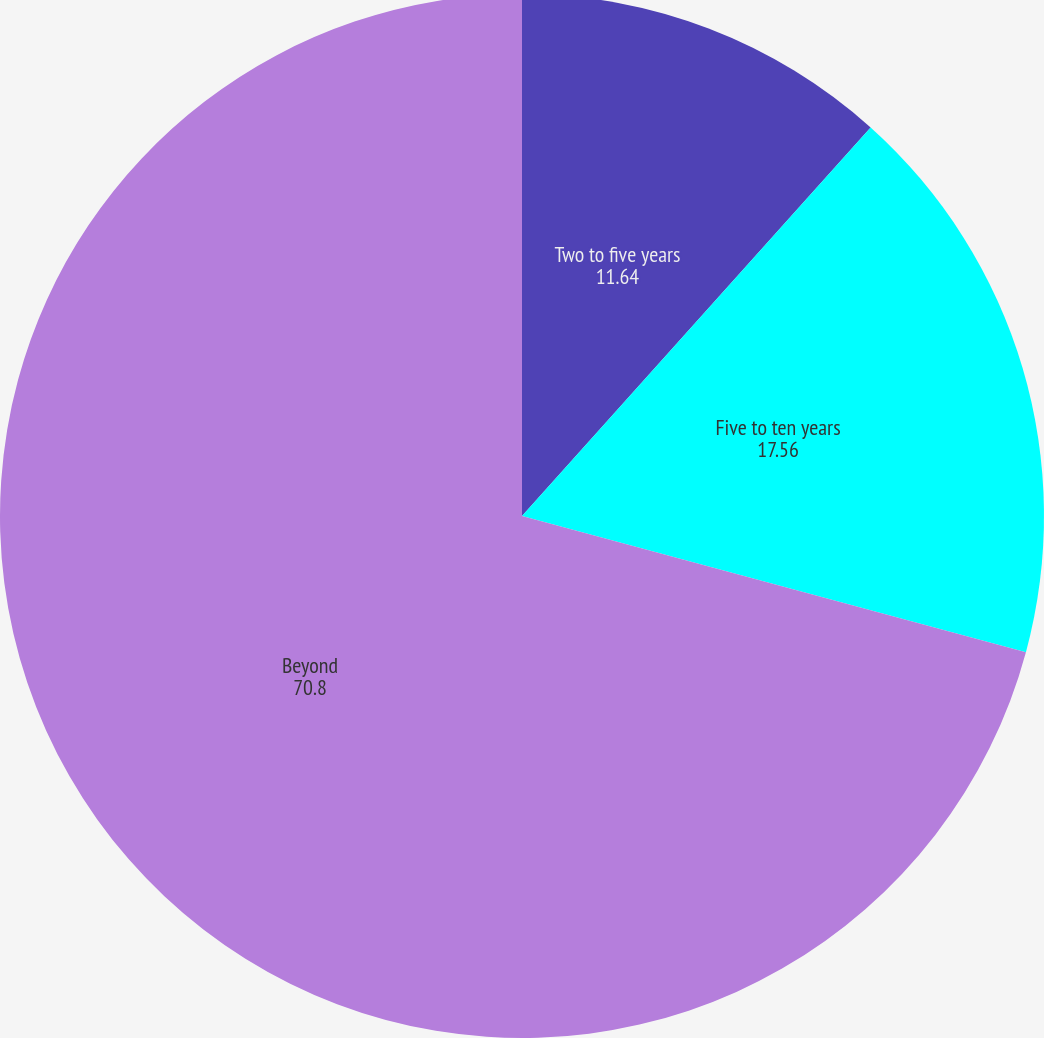Convert chart. <chart><loc_0><loc_0><loc_500><loc_500><pie_chart><fcel>Two to five years<fcel>Five to ten years<fcel>Beyond<nl><fcel>11.64%<fcel>17.56%<fcel>70.8%<nl></chart> 